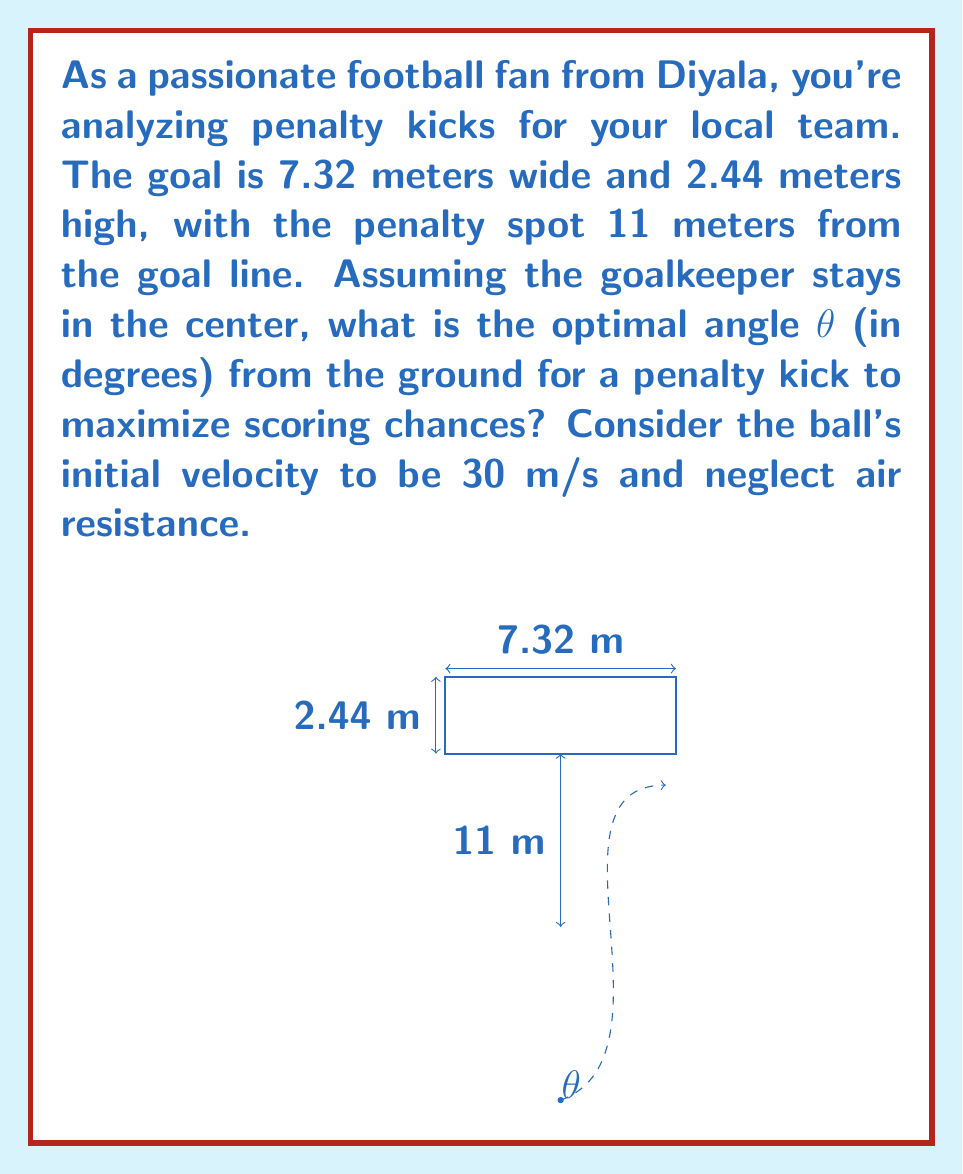Could you help me with this problem? To solve this problem, we'll use projectile motion equations and optimization techniques:

1) The range equation for a projectile is:
   $$R = \frac{v_0^2 \sin(2\theta)}{g}$$
   where R is the range, $v_0$ is initial velocity, θ is the launch angle, and g is gravity (9.8 m/s²).

2) We want to maximize the vertical displacement at 11 meters (the goal line). The vertical displacement equation is:
   $$y = x \tan(\theta) - \frac{gx^2}{2v_0^2 \cos^2(\theta)}$$
   where x is the horizontal distance (11 m in this case).

3) Substitute x = 11 and $v_0 = 30$ into the equation:
   $$y = 11 \tan(\theta) - \frac{9.8 \cdot 11^2}{2 \cdot 30^2 \cos^2(\theta)}$$

4) To find the maximum y, we differentiate with respect to θ and set it to zero:
   $$\frac{dy}{d\theta} = 11 \sec^2(\theta) - \frac{9.8 \cdot 11^2}{30^2} \cdot \frac{2\sin(\theta)}{\cos^3(\theta)} = 0$$

5) Solving this equation numerically (as it's too complex for analytical solution) gives us:
   $$\theta \approx 0.3491 \text{ radians}$$

6) Convert to degrees:
   $$\theta \approx 0.3491 \cdot \frac{180}{\pi} \approx 20.0°$$

This angle maximizes the ball's height at the goal line, giving the best chance to score over the goalkeeper.
Answer: $20.0°$ 